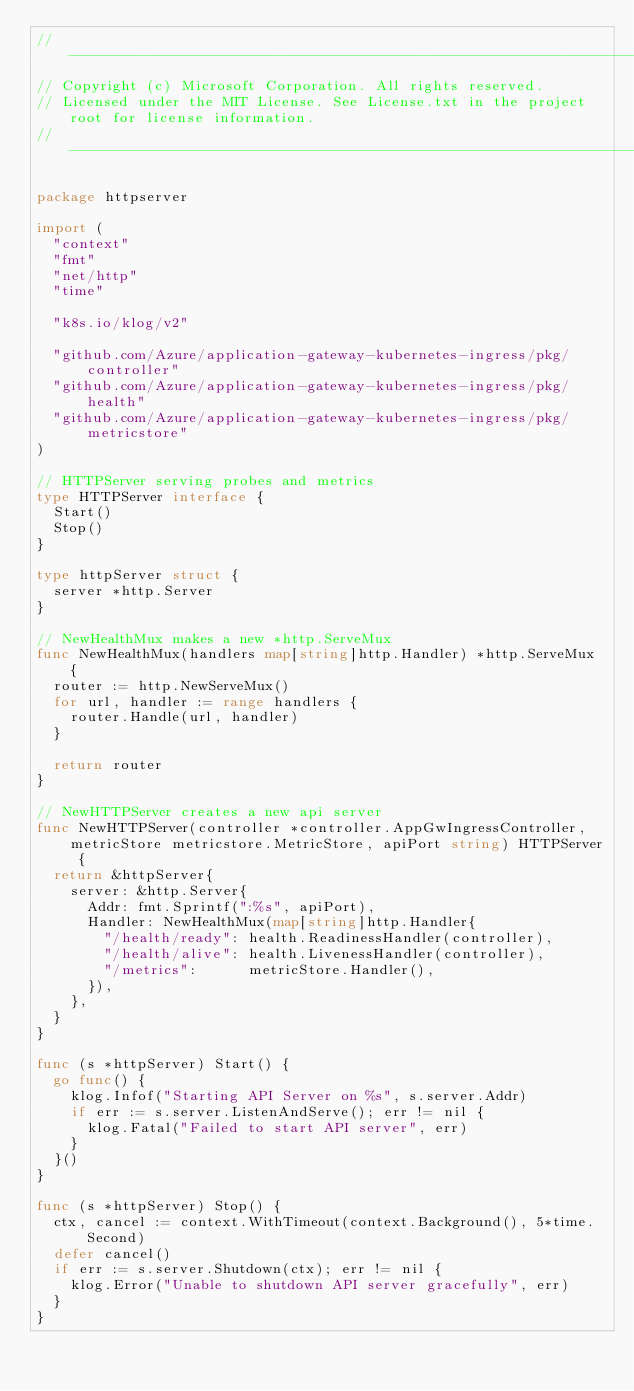Convert code to text. <code><loc_0><loc_0><loc_500><loc_500><_Go_>// -------------------------------------------------------------------------------------------
// Copyright (c) Microsoft Corporation. All rights reserved.
// Licensed under the MIT License. See License.txt in the project root for license information.
// --------------------------------------------------------------------------------------------

package httpserver

import (
	"context"
	"fmt"
	"net/http"
	"time"

	"k8s.io/klog/v2"

	"github.com/Azure/application-gateway-kubernetes-ingress/pkg/controller"
	"github.com/Azure/application-gateway-kubernetes-ingress/pkg/health"
	"github.com/Azure/application-gateway-kubernetes-ingress/pkg/metricstore"
)

// HTTPServer serving probes and metrics
type HTTPServer interface {
	Start()
	Stop()
}

type httpServer struct {
	server *http.Server
}

// NewHealthMux makes a new *http.ServeMux
func NewHealthMux(handlers map[string]http.Handler) *http.ServeMux {
	router := http.NewServeMux()
	for url, handler := range handlers {
		router.Handle(url, handler)
	}

	return router
}

// NewHTTPServer creates a new api server
func NewHTTPServer(controller *controller.AppGwIngressController, metricStore metricstore.MetricStore, apiPort string) HTTPServer {
	return &httpServer{
		server: &http.Server{
			Addr: fmt.Sprintf(":%s", apiPort),
			Handler: NewHealthMux(map[string]http.Handler{
				"/health/ready": health.ReadinessHandler(controller),
				"/health/alive": health.LivenessHandler(controller),
				"/metrics":      metricStore.Handler(),
			}),
		},
	}
}

func (s *httpServer) Start() {
	go func() {
		klog.Infof("Starting API Server on %s", s.server.Addr)
		if err := s.server.ListenAndServe(); err != nil {
			klog.Fatal("Failed to start API server", err)
		}
	}()
}

func (s *httpServer) Stop() {
	ctx, cancel := context.WithTimeout(context.Background(), 5*time.Second)
	defer cancel()
	if err := s.server.Shutdown(ctx); err != nil {
		klog.Error("Unable to shutdown API server gracefully", err)
	}
}
</code> 